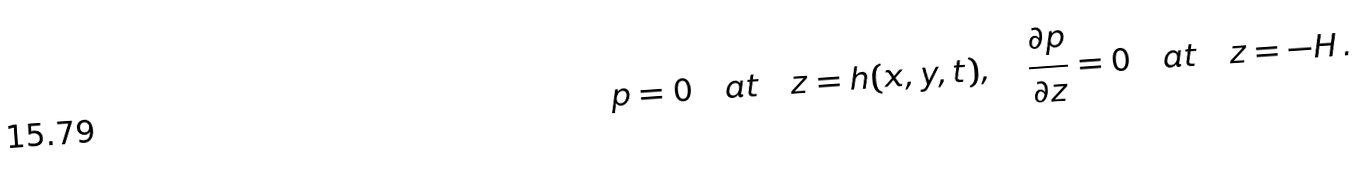Convert formula to latex. <formula><loc_0><loc_0><loc_500><loc_500>p = 0 \quad a t \quad z = h ( x , y , t ) , \quad \frac { \partial p } { \partial z } = 0 \quad a t \quad z = - H \, .</formula> 